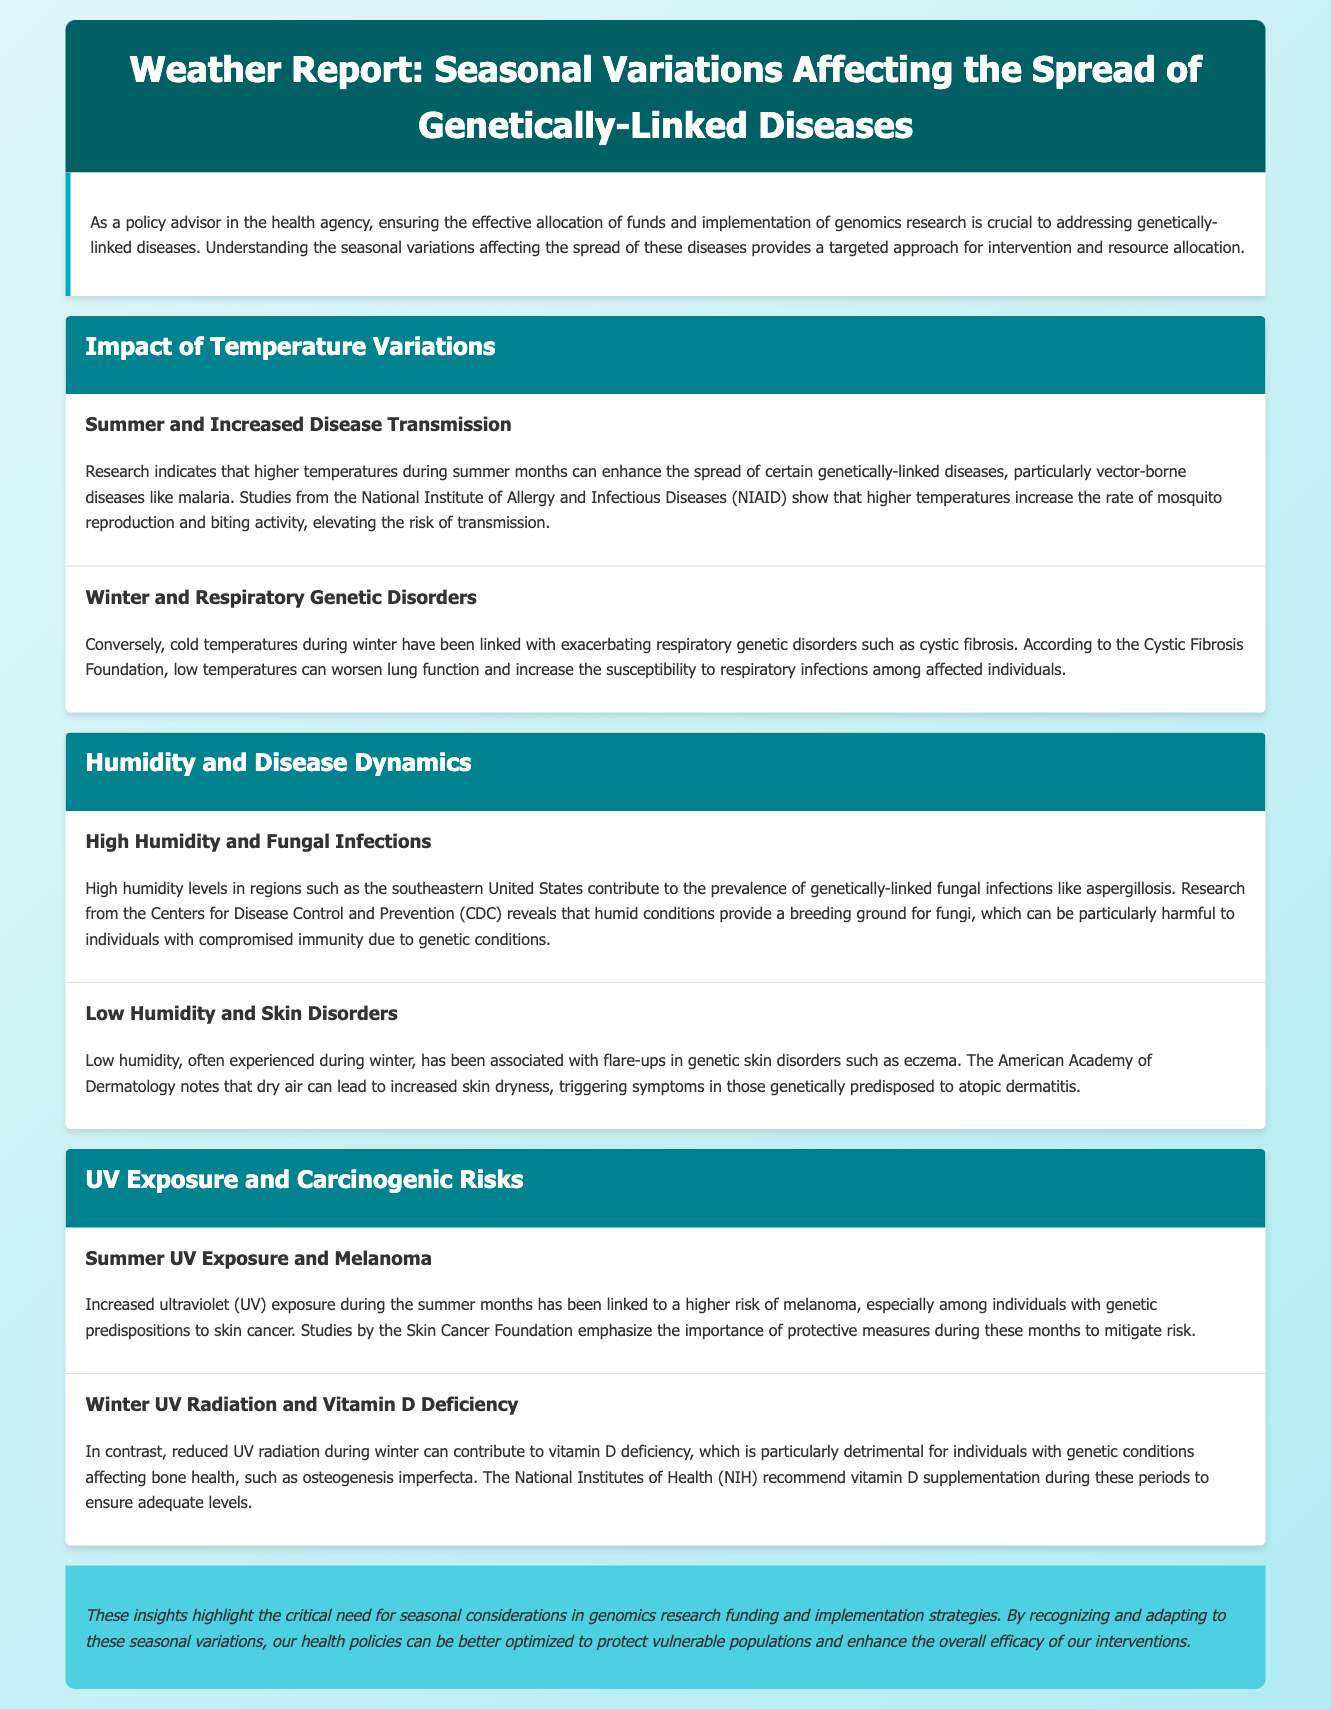What seasonal factor increases malaria transmission? Higher temperatures during summer months enhance the spread of malaria due to increased mosquito reproduction and biting activity.
Answer: Temperature What genetic disorder is exacerbated by cold temperatures? Cold temperatures during winter can worsen respiratory genetic disorders such as cystic fibrosis.
Answer: Cystic fibrosis Which organization highlights the risks associated with UV exposure during summer? The Skin Cancer Foundation emphasizes the importance of protective measures during the summer months to mitigate melanoma risk.
Answer: Skin Cancer Foundation What condition is linked to high humidity levels? High humidity contributes to the prevalence of genetically-linked fungal infections like aspergillosis.
Answer: Aspergillosis What can low humidity trigger in genetically predisposed individuals? Low humidity can lead to increased skin dryness, triggering symptoms in those genetically predisposed to atopic dermatitis like eczema.
Answer: Eczema What is the relationship between winter UV radiation and vitamin D? Reduced UV radiation during winter can contribute to vitamin D deficiency, particularly in individuals with genetic bone health conditions.
Answer: Vitamin D deficiency Which disease is mentioned in connection with summer UV exposure? Increased UV exposure during the summer months has been linked to a higher risk of melanoma.
Answer: Melanoma What is the recommended intervention during winter for bone health? The National Institutes of Health recommend vitamin D supplementation during winter to ensure adequate levels.
Answer: Vitamin D supplementation 